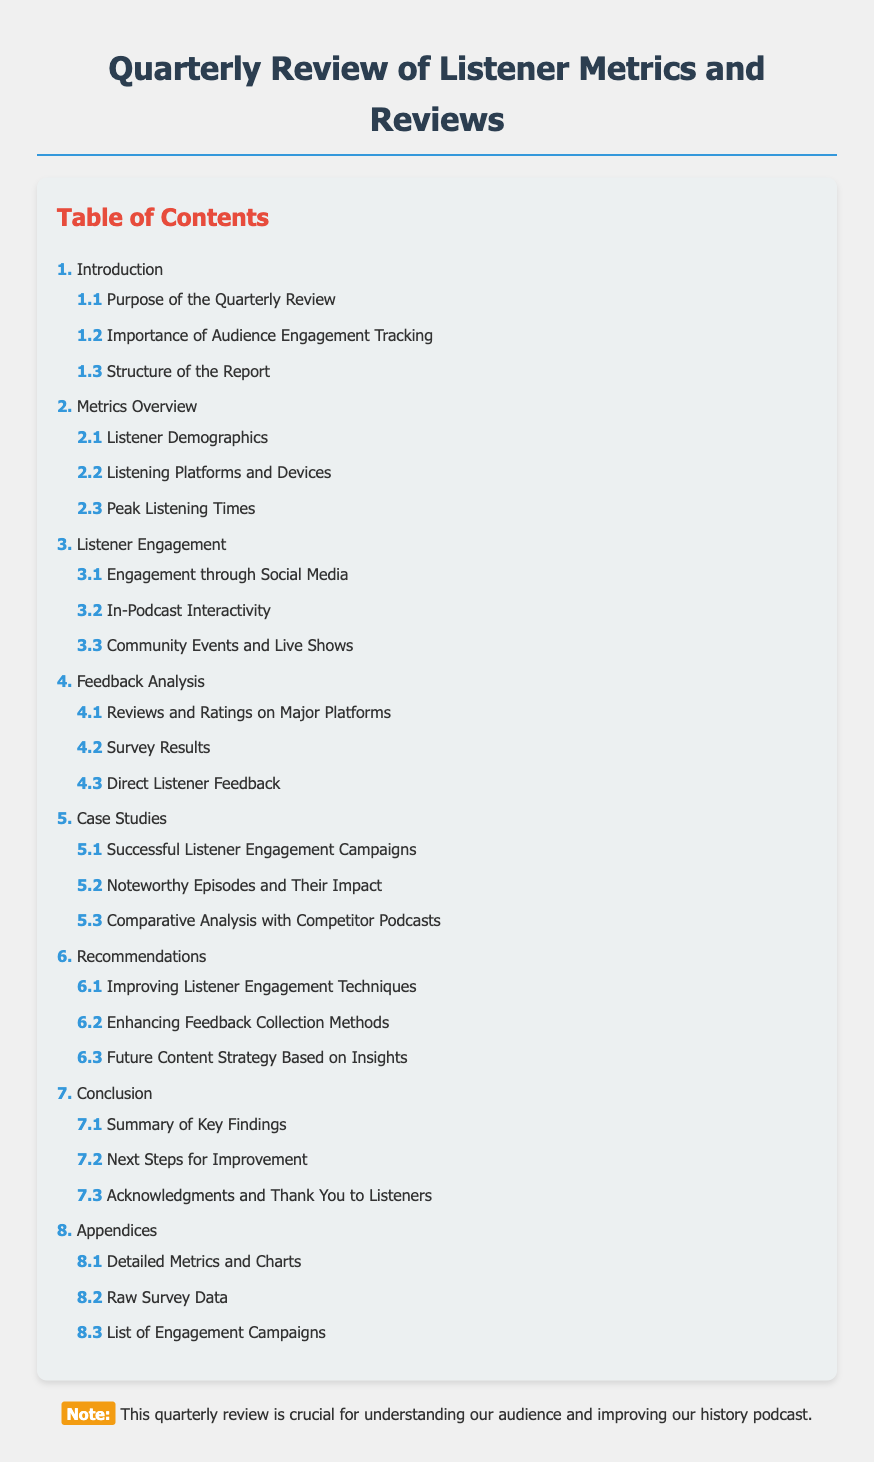What is the main topic of the document? The main topic is indicated in the title of the document, which is a review of audience engagement and listener metrics and reviews.
Answer: Listener Metrics and Reviews What section addresses the importance of tracking audience engagement? The section that discusses this is clearly labeled within the contents.
Answer: Importance of Audience Engagement Tracking How many case studies are included in this report? The table of contents lists specific sections, and the number of case studies can be directly identified from this section.
Answer: 3 What type of feedback is analyzed in the report? The table of contents mentions categories of feedback, including surveys and direct feedback.
Answer: Direct Listener Feedback Which section includes recommendations for improvement? The section containing these recommendations is specified in the table of contents.
Answer: Recommendations What is the purpose of the quarterly review? The purpose is outlined in the introduction section of the document.
Answer: Purpose of the Quarterly Review In what section can we find detailed metrics and charts? The section related to detailed metrics is found in the appendices section of the document.
Answer: Detailed Metrics and Charts What are the components of the feedback analysis? The components are outlined in the relevant section and include various sources of feedback.
Answer: Reviews and Ratings on Major Platforms, Survey Results, Direct Listener Feedback What is the title of the conclusion section? The conclusion section has specific subsections, which can be determined by examining the headings.
Answer: Summary of Key Findings 